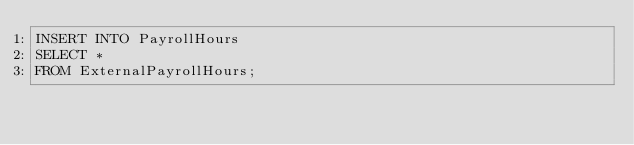<code> <loc_0><loc_0><loc_500><loc_500><_SQL_>INSERT INTO PayrollHours
SELECT *
FROM ExternalPayrollHours;
</code> 